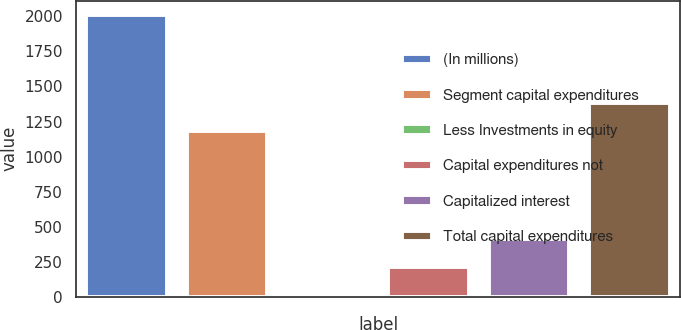Convert chart. <chart><loc_0><loc_0><loc_500><loc_500><bar_chart><fcel>(In millions)<fcel>Segment capital expenditures<fcel>Less Investments in equity<fcel>Capital expenditures not<fcel>Capitalized interest<fcel>Total capital expenditures<nl><fcel>2011<fcel>1185<fcel>11<fcel>211<fcel>411<fcel>1385<nl></chart> 